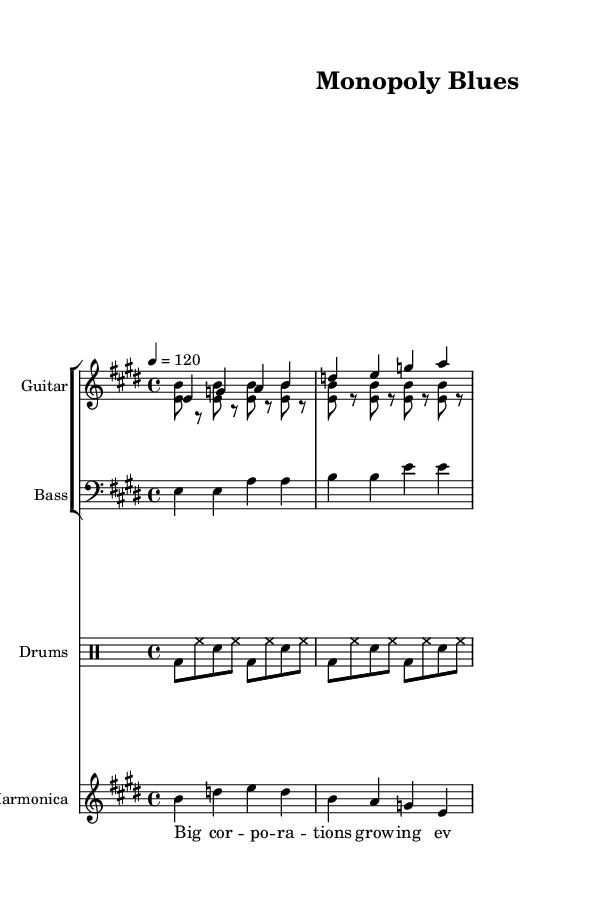what is the key signature of this music? The key signature is E major, which has four sharps (F#, C#, G#, and D#). This is determined by looking at the initial part of the music, where the key signature is indicated before the staff.
Answer: E major what is the time signature of the piece? The time signature is 4/4, which is indicated at the beginning of the score. This means there are four beats in each measure.
Answer: 4/4 what is the tempo marking of the piece? The tempo marking is 120 beats per minute, found in the tempo indication section at the beginning of the score. This number represents the speed of the piece.
Answer: 120 how many verses are in the lyrics? The lyrics consist of one verse followed by the chorus. The verse is indicated in a separate section from the chorus, which shows the structure of the lyrics.
Answer: One what is the function of the harmonica in this piece? The harmonica provides melodic embellishments, typically responding to the guitar parts. The separate staff for the harmonica indicates its role as an important solo instrument in the context of Electric Blues.
Answer: Melody why is the phrase "Rich get richer, what can we do?" significant in this music? This phrase critiques wealth inequality and corporate power, highlighting a central theme of economic disparity. It connects the musical content with the socio-economic message of the piece, making it a central lyrical element in reflecting the Electric Blues tradition.
Answer: Wealth inequality 